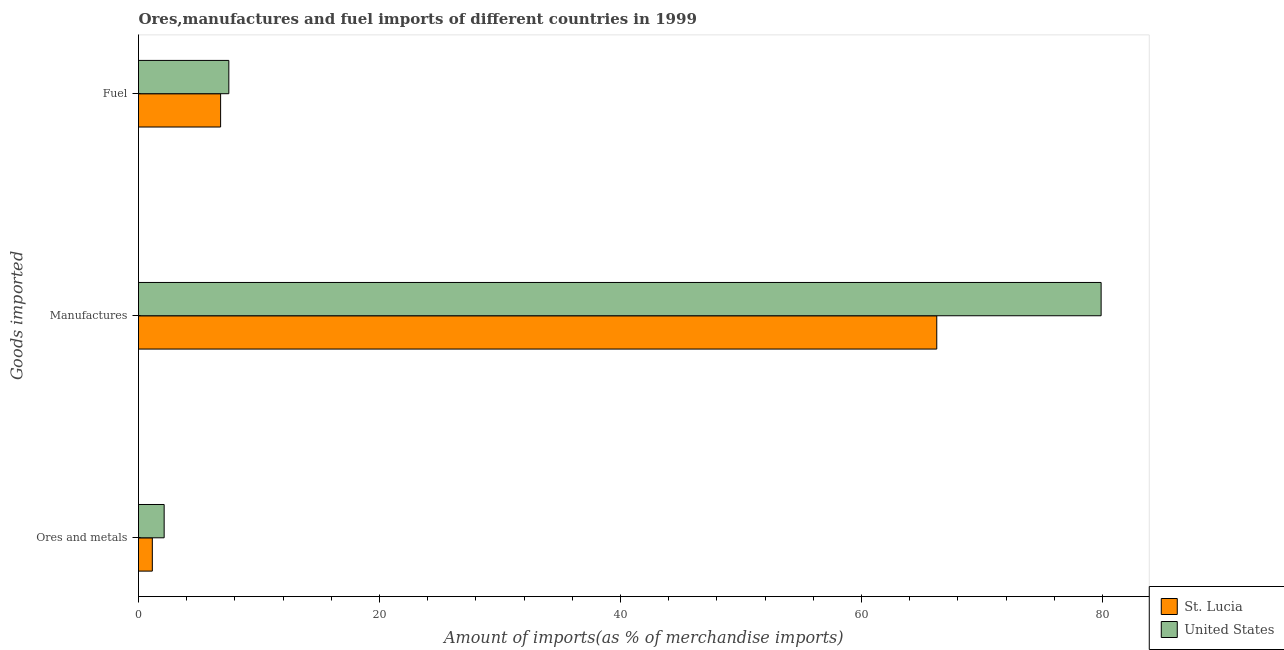Are the number of bars per tick equal to the number of legend labels?
Offer a very short reply. Yes. Are the number of bars on each tick of the Y-axis equal?
Provide a short and direct response. Yes. What is the label of the 3rd group of bars from the top?
Your answer should be very brief. Ores and metals. What is the percentage of manufactures imports in St. Lucia?
Make the answer very short. 66.25. Across all countries, what is the maximum percentage of manufactures imports?
Offer a terse response. 79.9. Across all countries, what is the minimum percentage of ores and metals imports?
Offer a terse response. 1.15. In which country was the percentage of ores and metals imports maximum?
Make the answer very short. United States. In which country was the percentage of manufactures imports minimum?
Provide a succinct answer. St. Lucia. What is the total percentage of manufactures imports in the graph?
Give a very brief answer. 146.15. What is the difference between the percentage of manufactures imports in United States and that in St. Lucia?
Offer a very short reply. 13.64. What is the difference between the percentage of ores and metals imports in St. Lucia and the percentage of manufactures imports in United States?
Give a very brief answer. -78.75. What is the average percentage of fuel imports per country?
Your answer should be very brief. 7.16. What is the difference between the percentage of manufactures imports and percentage of ores and metals imports in St. Lucia?
Your response must be concise. 65.11. What is the ratio of the percentage of manufactures imports in St. Lucia to that in United States?
Ensure brevity in your answer.  0.83. Is the percentage of manufactures imports in St. Lucia less than that in United States?
Ensure brevity in your answer.  Yes. Is the difference between the percentage of manufactures imports in United States and St. Lucia greater than the difference between the percentage of fuel imports in United States and St. Lucia?
Keep it short and to the point. Yes. What is the difference between the highest and the second highest percentage of manufactures imports?
Your response must be concise. 13.64. What is the difference between the highest and the lowest percentage of fuel imports?
Offer a very short reply. 0.68. In how many countries, is the percentage of manufactures imports greater than the average percentage of manufactures imports taken over all countries?
Your response must be concise. 1. What does the 2nd bar from the top in Fuel represents?
Keep it short and to the point. St. Lucia. Is it the case that in every country, the sum of the percentage of ores and metals imports and percentage of manufactures imports is greater than the percentage of fuel imports?
Make the answer very short. Yes. How many countries are there in the graph?
Offer a very short reply. 2. What is the difference between two consecutive major ticks on the X-axis?
Offer a terse response. 20. Where does the legend appear in the graph?
Your answer should be compact. Bottom right. How are the legend labels stacked?
Offer a terse response. Vertical. What is the title of the graph?
Provide a short and direct response. Ores,manufactures and fuel imports of different countries in 1999. Does "Burkina Faso" appear as one of the legend labels in the graph?
Your answer should be compact. No. What is the label or title of the X-axis?
Your answer should be compact. Amount of imports(as % of merchandise imports). What is the label or title of the Y-axis?
Your answer should be very brief. Goods imported. What is the Amount of imports(as % of merchandise imports) in St. Lucia in Ores and metals?
Your answer should be very brief. 1.15. What is the Amount of imports(as % of merchandise imports) of United States in Ores and metals?
Your answer should be compact. 2.13. What is the Amount of imports(as % of merchandise imports) in St. Lucia in Manufactures?
Make the answer very short. 66.25. What is the Amount of imports(as % of merchandise imports) in United States in Manufactures?
Your response must be concise. 79.9. What is the Amount of imports(as % of merchandise imports) in St. Lucia in Fuel?
Your answer should be very brief. 6.81. What is the Amount of imports(as % of merchandise imports) of United States in Fuel?
Your answer should be compact. 7.5. Across all Goods imported, what is the maximum Amount of imports(as % of merchandise imports) in St. Lucia?
Make the answer very short. 66.25. Across all Goods imported, what is the maximum Amount of imports(as % of merchandise imports) in United States?
Offer a terse response. 79.9. Across all Goods imported, what is the minimum Amount of imports(as % of merchandise imports) of St. Lucia?
Your answer should be very brief. 1.15. Across all Goods imported, what is the minimum Amount of imports(as % of merchandise imports) of United States?
Keep it short and to the point. 2.13. What is the total Amount of imports(as % of merchandise imports) of St. Lucia in the graph?
Provide a succinct answer. 74.22. What is the total Amount of imports(as % of merchandise imports) of United States in the graph?
Offer a terse response. 89.52. What is the difference between the Amount of imports(as % of merchandise imports) of St. Lucia in Ores and metals and that in Manufactures?
Provide a succinct answer. -65.11. What is the difference between the Amount of imports(as % of merchandise imports) in United States in Ores and metals and that in Manufactures?
Your answer should be compact. -77.77. What is the difference between the Amount of imports(as % of merchandise imports) in St. Lucia in Ores and metals and that in Fuel?
Provide a succinct answer. -5.67. What is the difference between the Amount of imports(as % of merchandise imports) in United States in Ores and metals and that in Fuel?
Offer a very short reply. -5.37. What is the difference between the Amount of imports(as % of merchandise imports) in St. Lucia in Manufactures and that in Fuel?
Offer a terse response. 59.44. What is the difference between the Amount of imports(as % of merchandise imports) in United States in Manufactures and that in Fuel?
Ensure brevity in your answer.  72.4. What is the difference between the Amount of imports(as % of merchandise imports) of St. Lucia in Ores and metals and the Amount of imports(as % of merchandise imports) of United States in Manufactures?
Offer a terse response. -78.75. What is the difference between the Amount of imports(as % of merchandise imports) of St. Lucia in Ores and metals and the Amount of imports(as % of merchandise imports) of United States in Fuel?
Offer a very short reply. -6.35. What is the difference between the Amount of imports(as % of merchandise imports) in St. Lucia in Manufactures and the Amount of imports(as % of merchandise imports) in United States in Fuel?
Ensure brevity in your answer.  58.76. What is the average Amount of imports(as % of merchandise imports) of St. Lucia per Goods imported?
Keep it short and to the point. 24.74. What is the average Amount of imports(as % of merchandise imports) in United States per Goods imported?
Offer a terse response. 29.84. What is the difference between the Amount of imports(as % of merchandise imports) in St. Lucia and Amount of imports(as % of merchandise imports) in United States in Ores and metals?
Give a very brief answer. -0.98. What is the difference between the Amount of imports(as % of merchandise imports) of St. Lucia and Amount of imports(as % of merchandise imports) of United States in Manufactures?
Your response must be concise. -13.64. What is the difference between the Amount of imports(as % of merchandise imports) of St. Lucia and Amount of imports(as % of merchandise imports) of United States in Fuel?
Make the answer very short. -0.68. What is the ratio of the Amount of imports(as % of merchandise imports) in St. Lucia in Ores and metals to that in Manufactures?
Offer a terse response. 0.02. What is the ratio of the Amount of imports(as % of merchandise imports) in United States in Ores and metals to that in Manufactures?
Offer a terse response. 0.03. What is the ratio of the Amount of imports(as % of merchandise imports) of St. Lucia in Ores and metals to that in Fuel?
Give a very brief answer. 0.17. What is the ratio of the Amount of imports(as % of merchandise imports) in United States in Ores and metals to that in Fuel?
Your answer should be compact. 0.28. What is the ratio of the Amount of imports(as % of merchandise imports) of St. Lucia in Manufactures to that in Fuel?
Make the answer very short. 9.72. What is the ratio of the Amount of imports(as % of merchandise imports) in United States in Manufactures to that in Fuel?
Give a very brief answer. 10.66. What is the difference between the highest and the second highest Amount of imports(as % of merchandise imports) in St. Lucia?
Offer a very short reply. 59.44. What is the difference between the highest and the second highest Amount of imports(as % of merchandise imports) of United States?
Ensure brevity in your answer.  72.4. What is the difference between the highest and the lowest Amount of imports(as % of merchandise imports) in St. Lucia?
Make the answer very short. 65.11. What is the difference between the highest and the lowest Amount of imports(as % of merchandise imports) of United States?
Make the answer very short. 77.77. 